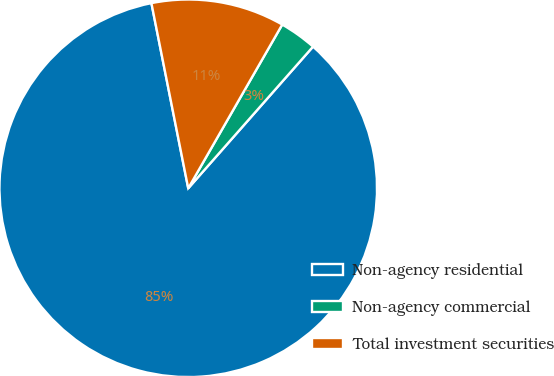Convert chart. <chart><loc_0><loc_0><loc_500><loc_500><pie_chart><fcel>Non-agency residential<fcel>Non-agency commercial<fcel>Total investment securities<nl><fcel>85.38%<fcel>3.2%<fcel>11.42%<nl></chart> 